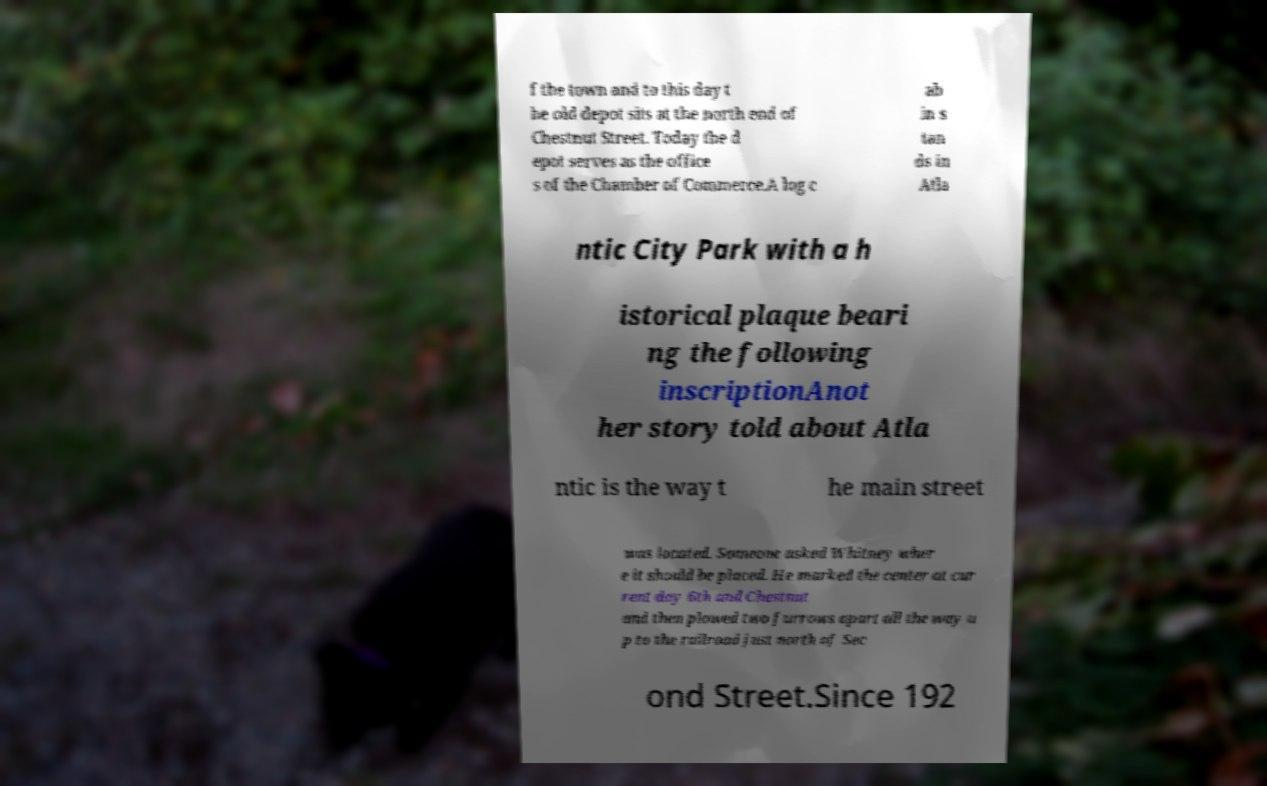There's text embedded in this image that I need extracted. Can you transcribe it verbatim? f the town and to this day t he old depot sits at the north end of Chestnut Street. Today the d epot serves as the office s of the Chamber of Commerce.A log c ab in s tan ds in Atla ntic City Park with a h istorical plaque beari ng the following inscriptionAnot her story told about Atla ntic is the way t he main street was located. Someone asked Whitney wher e it should be placed. He marked the center at cur rent day 6th and Chestnut and then plowed two furrows apart all the way u p to the railroad just north of Sec ond Street.Since 192 